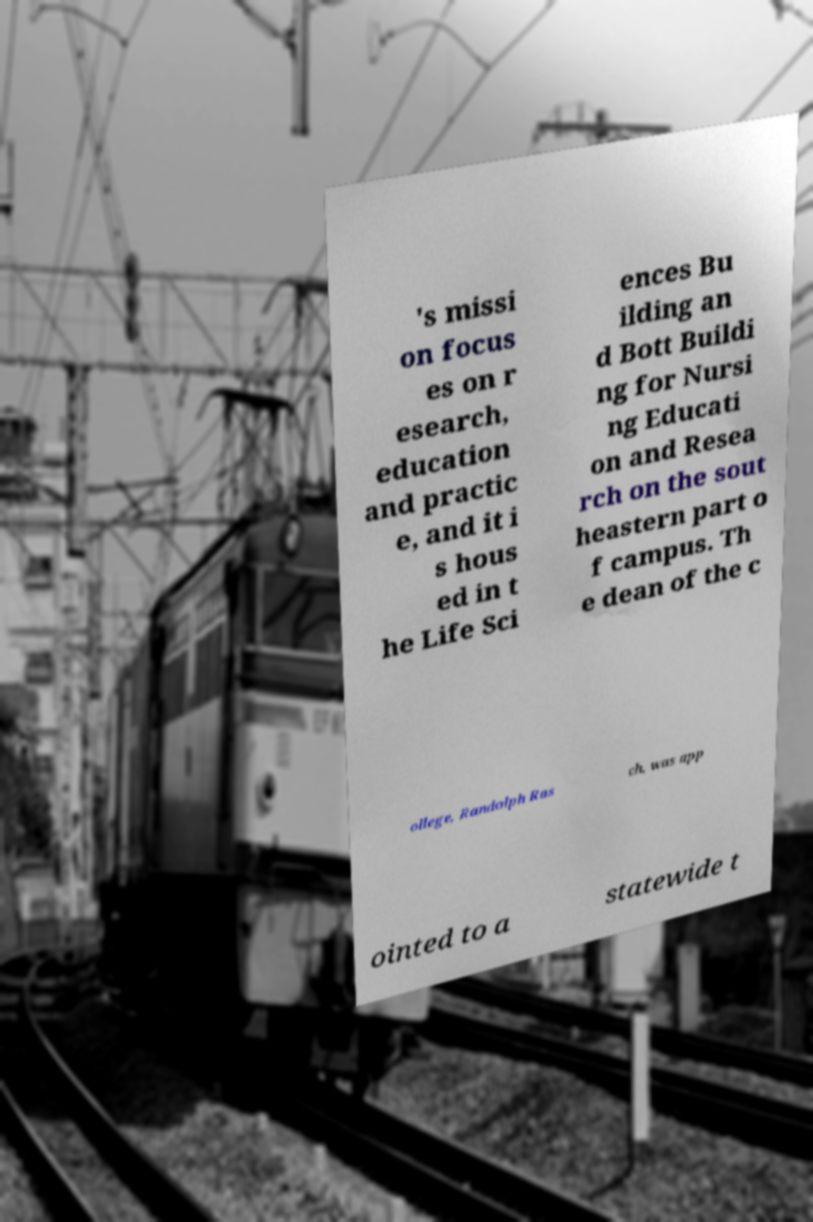For documentation purposes, I need the text within this image transcribed. Could you provide that? 's missi on focus es on r esearch, education and practic e, and it i s hous ed in t he Life Sci ences Bu ilding an d Bott Buildi ng for Nursi ng Educati on and Resea rch on the sout heastern part o f campus. Th e dean of the c ollege, Randolph Ras ch, was app ointed to a statewide t 